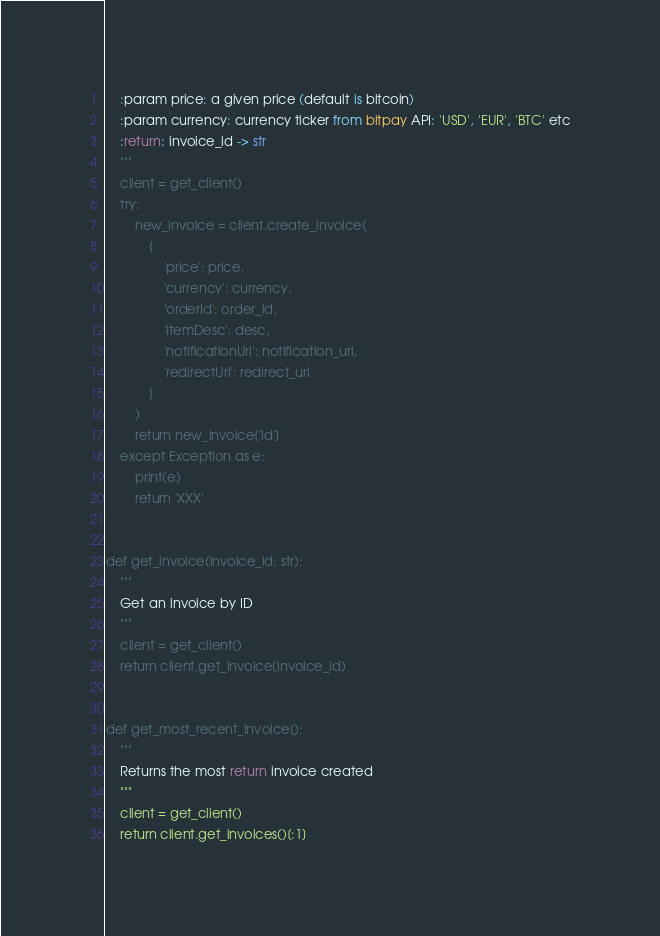Convert code to text. <code><loc_0><loc_0><loc_500><loc_500><_Python_>    :param price: a given price (default is bitcoin)
    :param currency: currency ticker from bitpay API: 'USD', 'EUR', 'BTC' etc
    :return: invoice_id -> str
    """
    client = get_client()
    try:
        new_invoice = client.create_invoice(
            {
                'price': price,
                'currency': currency,
                'orderId': order_id,
                'itemDesc': desc,
                'notificationUrl': notification_url,
                'redirectUrl': redirect_url
            }
        )
        return new_invoice['id']
    except Exception as e:
        print(e)
        return 'XXX'


def get_invoice(invoice_id: str):
    """
    Get an invoice by ID
    """
    client = get_client()
    return client.get_invoice(invoice_id)


def get_most_recent_invoice():
    """
    Returns the most return invoice created
    """
    client = get_client()
    return client.get_invoices()[:1]
</code> 